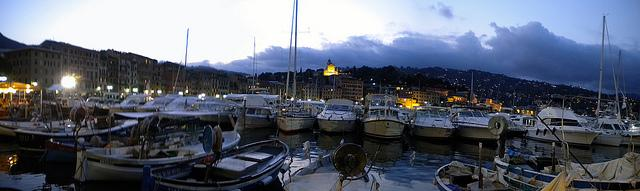What are the round objects on the boats used for? Please explain your reasoning. hoisting sails. There are long poles on the boats. 